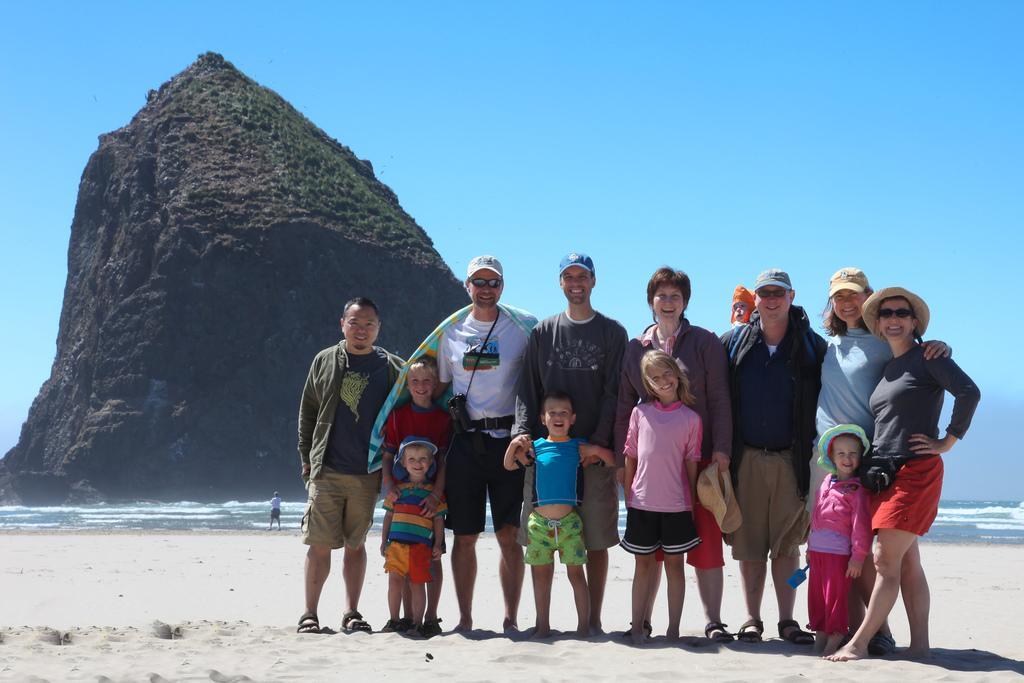Describe this image in one or two sentences. At the bottom of this image, there are persons, children and a woman in different color dresses, smiling and standing on a sand surface. In the background, there is another person at the tides of the ocean, there is a mountain and there are clouds in the blue sky. 